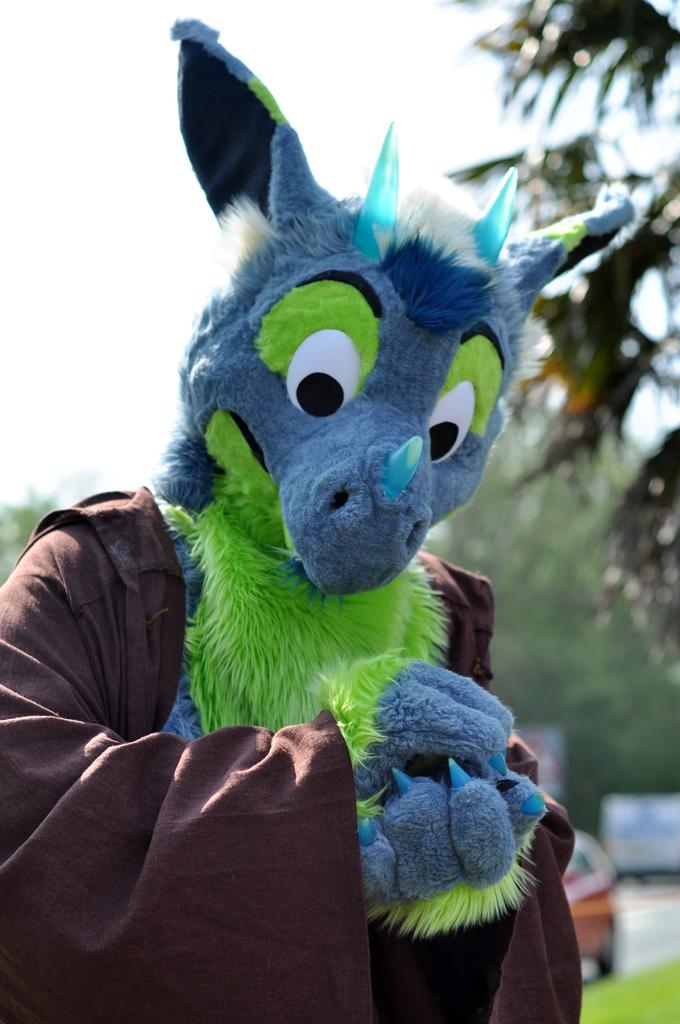What is present in the image? There is a person in the image. What is the person wearing? The person is wearing a cartoon costume. How is the background of the person depicted? The background of the person is blurred. What type of mask is the person wearing in the image? The person is not wearing a mask; they are wearing a cartoon costume. 